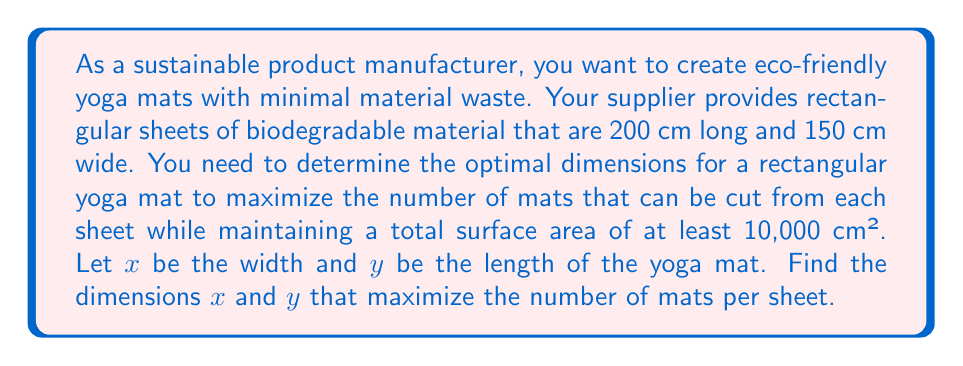What is the answer to this math problem? To solve this problem, we'll follow these steps:

1. Express the number of mats per sheet as a function of $x$ and $y$:
   $$N(x,y) = \left\lfloor\frac{200}{y}\right\rfloor \cdot \left\lfloor\frac{150}{x}\right\rfloor$$
   where $\lfloor \rfloor$ denotes the floor function.

2. Set up the constraints:
   a) Area constraint: $xy \geq 10000$
   b) Dimension constraints: $0 < x \leq 150$ and $0 < y \leq 200$

3. To maximize $N(x,y)$, we need to minimize both $x$ and $y$ while satisfying the constraints.

4. From the area constraint: $y \geq \frac{10000}{x}$

5. Substitute this into the $N(x,y)$ function:
   $$N(x) = \left\lfloor\frac{200x}{10000}\right\rfloor \cdot \left\lfloor\frac{150}{x}\right\rfloor$$

6. To maximize this function, we need to find the value of $x$ where the product of the two floor functions is highest.

7. The optimal solution will occur when both fractions are as close to integers as possible. This happens when:
   $$\frac{200x}{10000} = \frac{150}{x}$$

8. Solving this equation:
   $$x^2 = \frac{150 \cdot 10000}{200} = 7500$$
   $$x = \sqrt{7500} \approx 86.60$$

9. Round $x$ to the nearest centimeter: $x = 87$ cm

10. Calculate $y$:
    $$y = \frac{10000}{87} \approx 114.94$$
    Round up to ensure the area constraint is met: $y = 115$ cm

11. Verify the number of mats per sheet:
    $$N(87, 115) = \left\lfloor\frac{200}{115}\right\rfloor \cdot \left\lfloor\frac{150}{87}\right\rfloor = 1 \cdot 1 = 1$$

[asy]
size(200);
draw((0,0)--(150,0)--(150,200)--(0,200)--cycle);
draw((0,115)--(87,115)--(87,0), dashed);
label("200 cm", (150,100), E);
label("150 cm", (75,0), S);
label("115 cm", (0,57.5), W);
label("87 cm", (43.5,0), S);
[/asy]
Answer: The optimal dimensions for the yoga mat are 87 cm wide and 115 cm long. This allows for one mat to be cut from each sheet of material with minimal waste while meeting the minimum area requirement of 10,000 cm². 